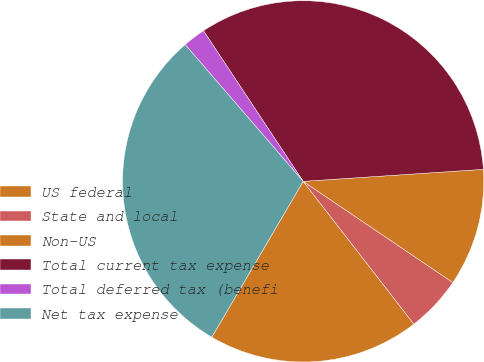Convert chart. <chart><loc_0><loc_0><loc_500><loc_500><pie_chart><fcel>US federal<fcel>State and local<fcel>Non-US<fcel>Total current tax expense<fcel>Total deferred tax (benefi<fcel>Net tax expense<nl><fcel>18.94%<fcel>5.04%<fcel>10.52%<fcel>33.25%<fcel>2.02%<fcel>30.23%<nl></chart> 